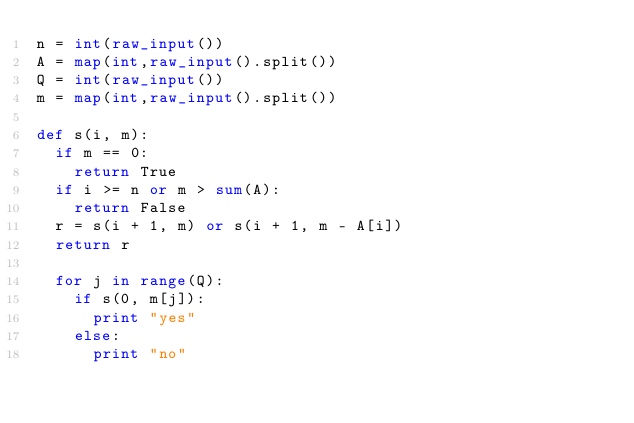Convert code to text. <code><loc_0><loc_0><loc_500><loc_500><_Python_>n = int(raw_input())
A = map(int,raw_input().split())
Q = int(raw_input())
m = map(int,raw_input().split())

def s(i, m):
  if m == 0:
    return True
  if i >= n or m > sum(A):
    return False
  r = s(i + 1, m) or s(i + 1, m - A[i])
  return r

  for j in range(Q):
    if s(0, m[j]):
      print "yes"
    else:
      print "no"
  
  </code> 